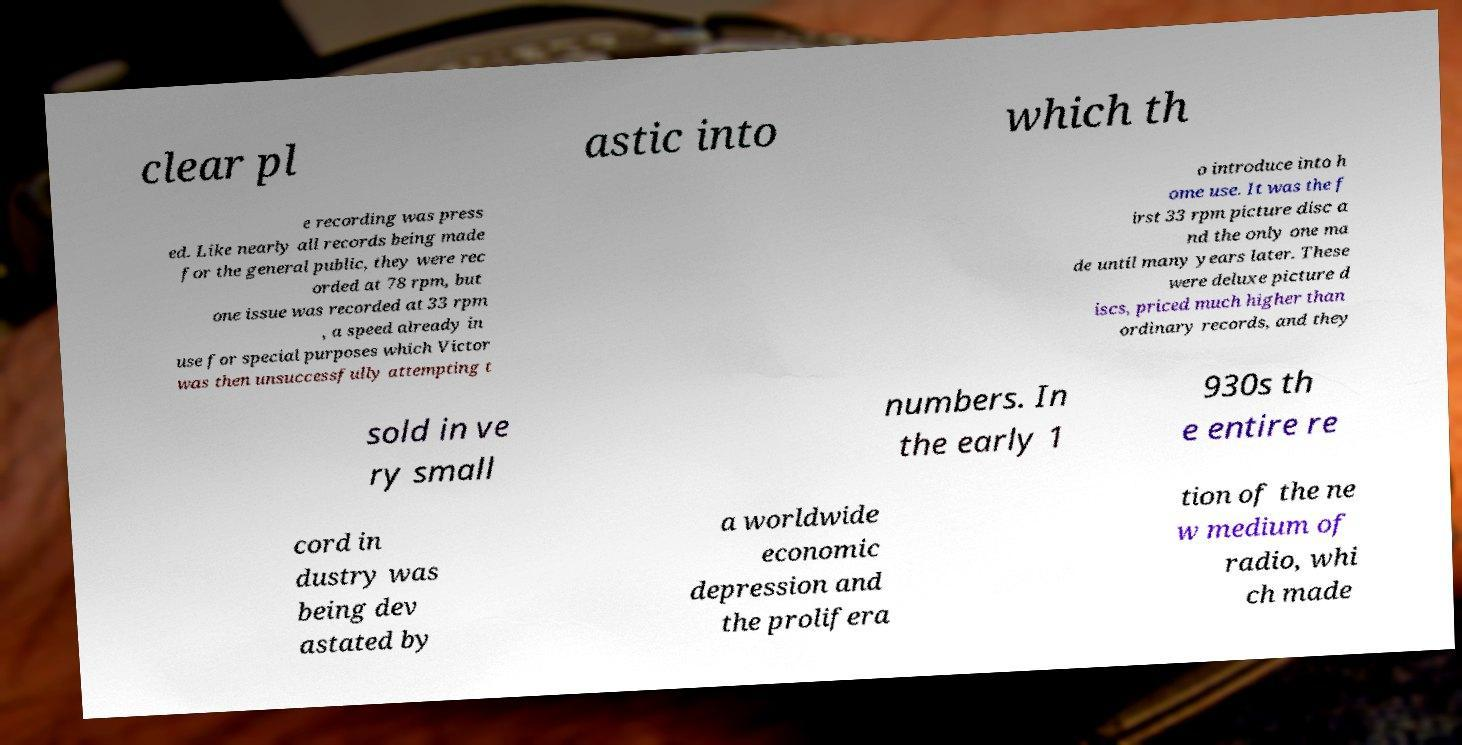Can you accurately transcribe the text from the provided image for me? clear pl astic into which th e recording was press ed. Like nearly all records being made for the general public, they were rec orded at 78 rpm, but one issue was recorded at 33 rpm , a speed already in use for special purposes which Victor was then unsuccessfully attempting t o introduce into h ome use. It was the f irst 33 rpm picture disc a nd the only one ma de until many years later. These were deluxe picture d iscs, priced much higher than ordinary records, and they sold in ve ry small numbers. In the early 1 930s th e entire re cord in dustry was being dev astated by a worldwide economic depression and the prolifera tion of the ne w medium of radio, whi ch made 